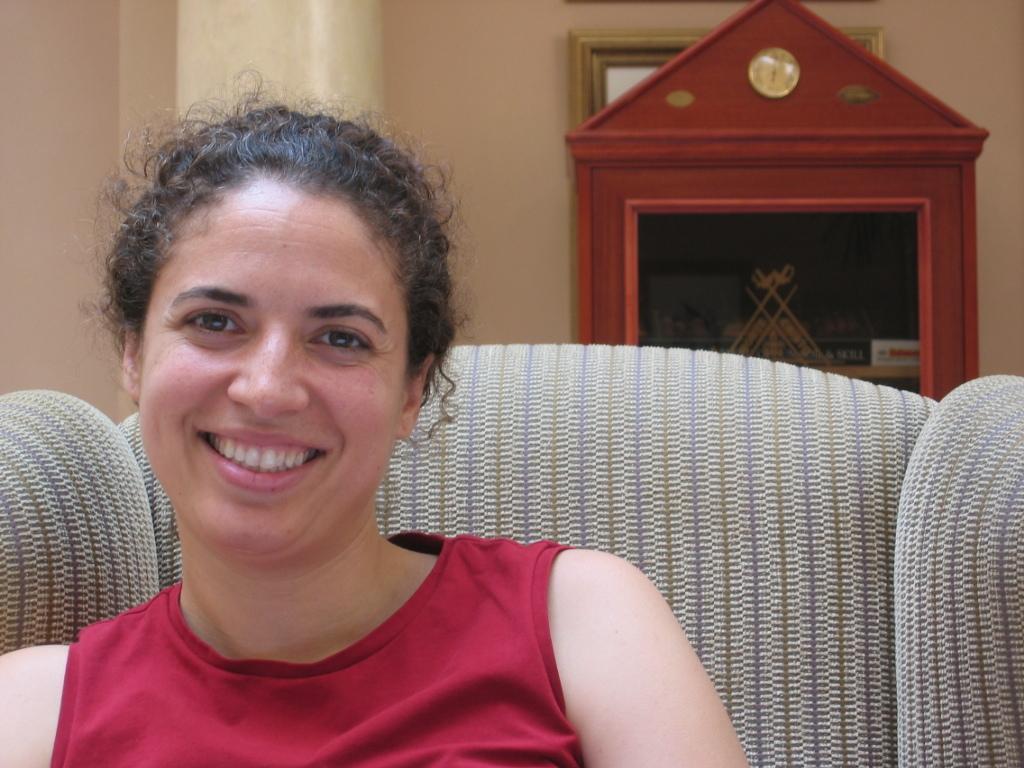Can you describe this image briefly? There is a lady sitting on the sofa in the foreground area of the image, it seems like a frame, a wooden rack and a pillar in the background. 